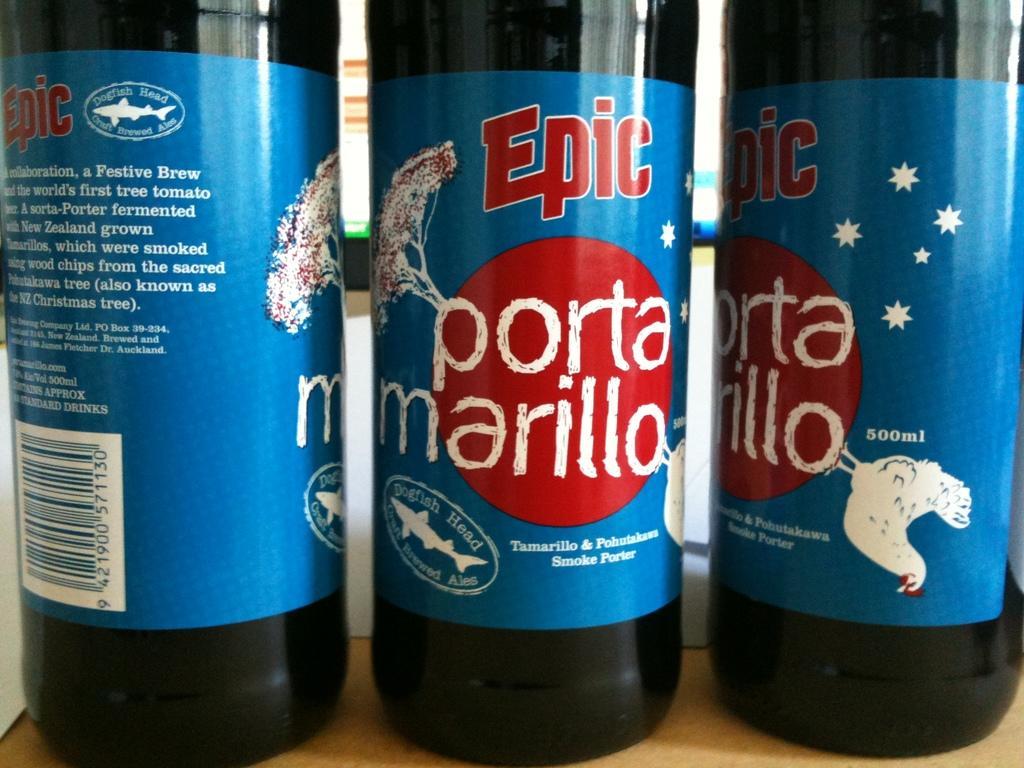In one or two sentences, can you explain what this image depicts? In this image I can see three bottles on the cream color surface and I can see few stickers on the bottles and the stickers are in blue color. 